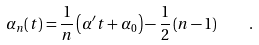Convert formula to latex. <formula><loc_0><loc_0><loc_500><loc_500>\alpha _ { n } ( t ) = \frac { 1 } { n } \left ( \alpha ^ { \prime } t + \alpha _ { 0 } \right ) - \frac { 1 } { 2 } \left ( n - 1 \right ) \quad .</formula> 